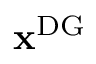Convert formula to latex. <formula><loc_0><loc_0><loc_500><loc_500>x ^ { D G }</formula> 